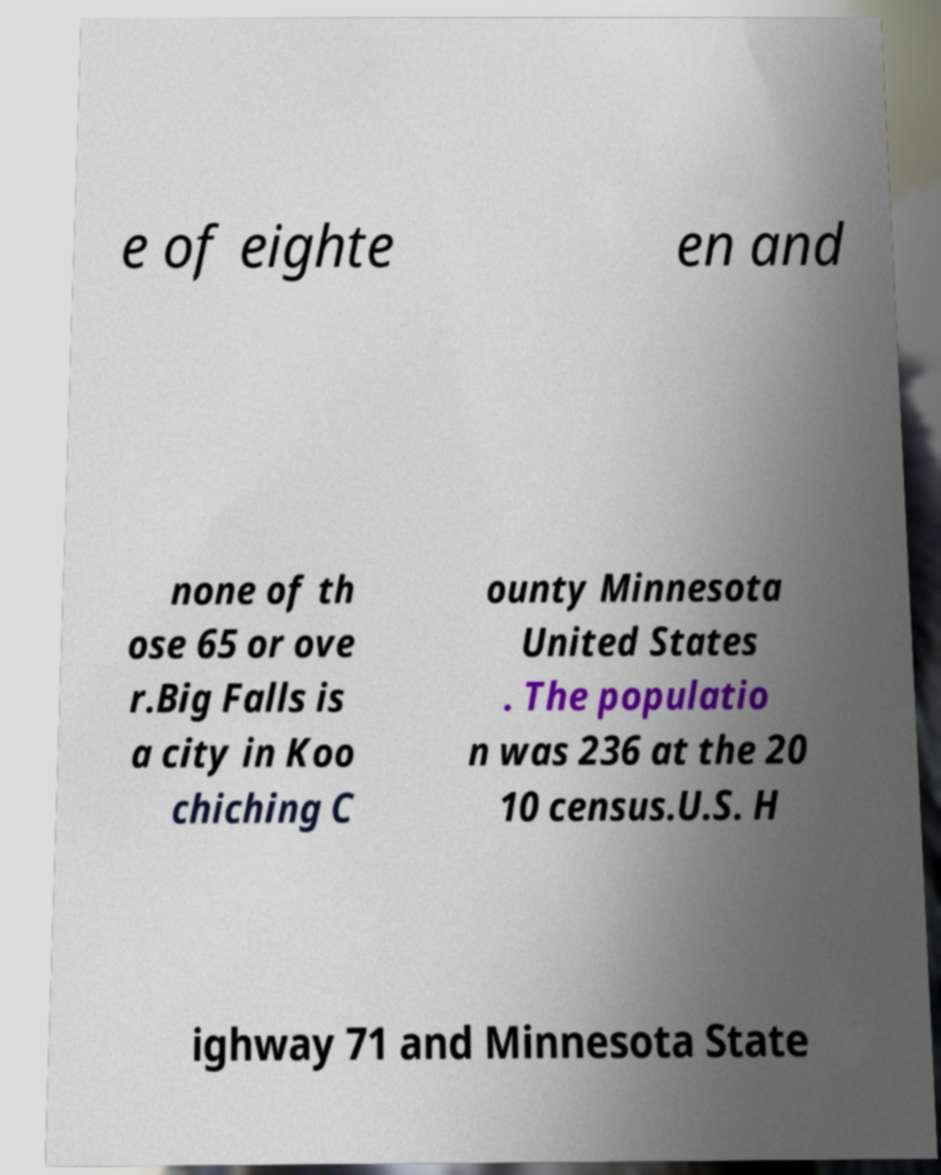I need the written content from this picture converted into text. Can you do that? e of eighte en and none of th ose 65 or ove r.Big Falls is a city in Koo chiching C ounty Minnesota United States . The populatio n was 236 at the 20 10 census.U.S. H ighway 71 and Minnesota State 